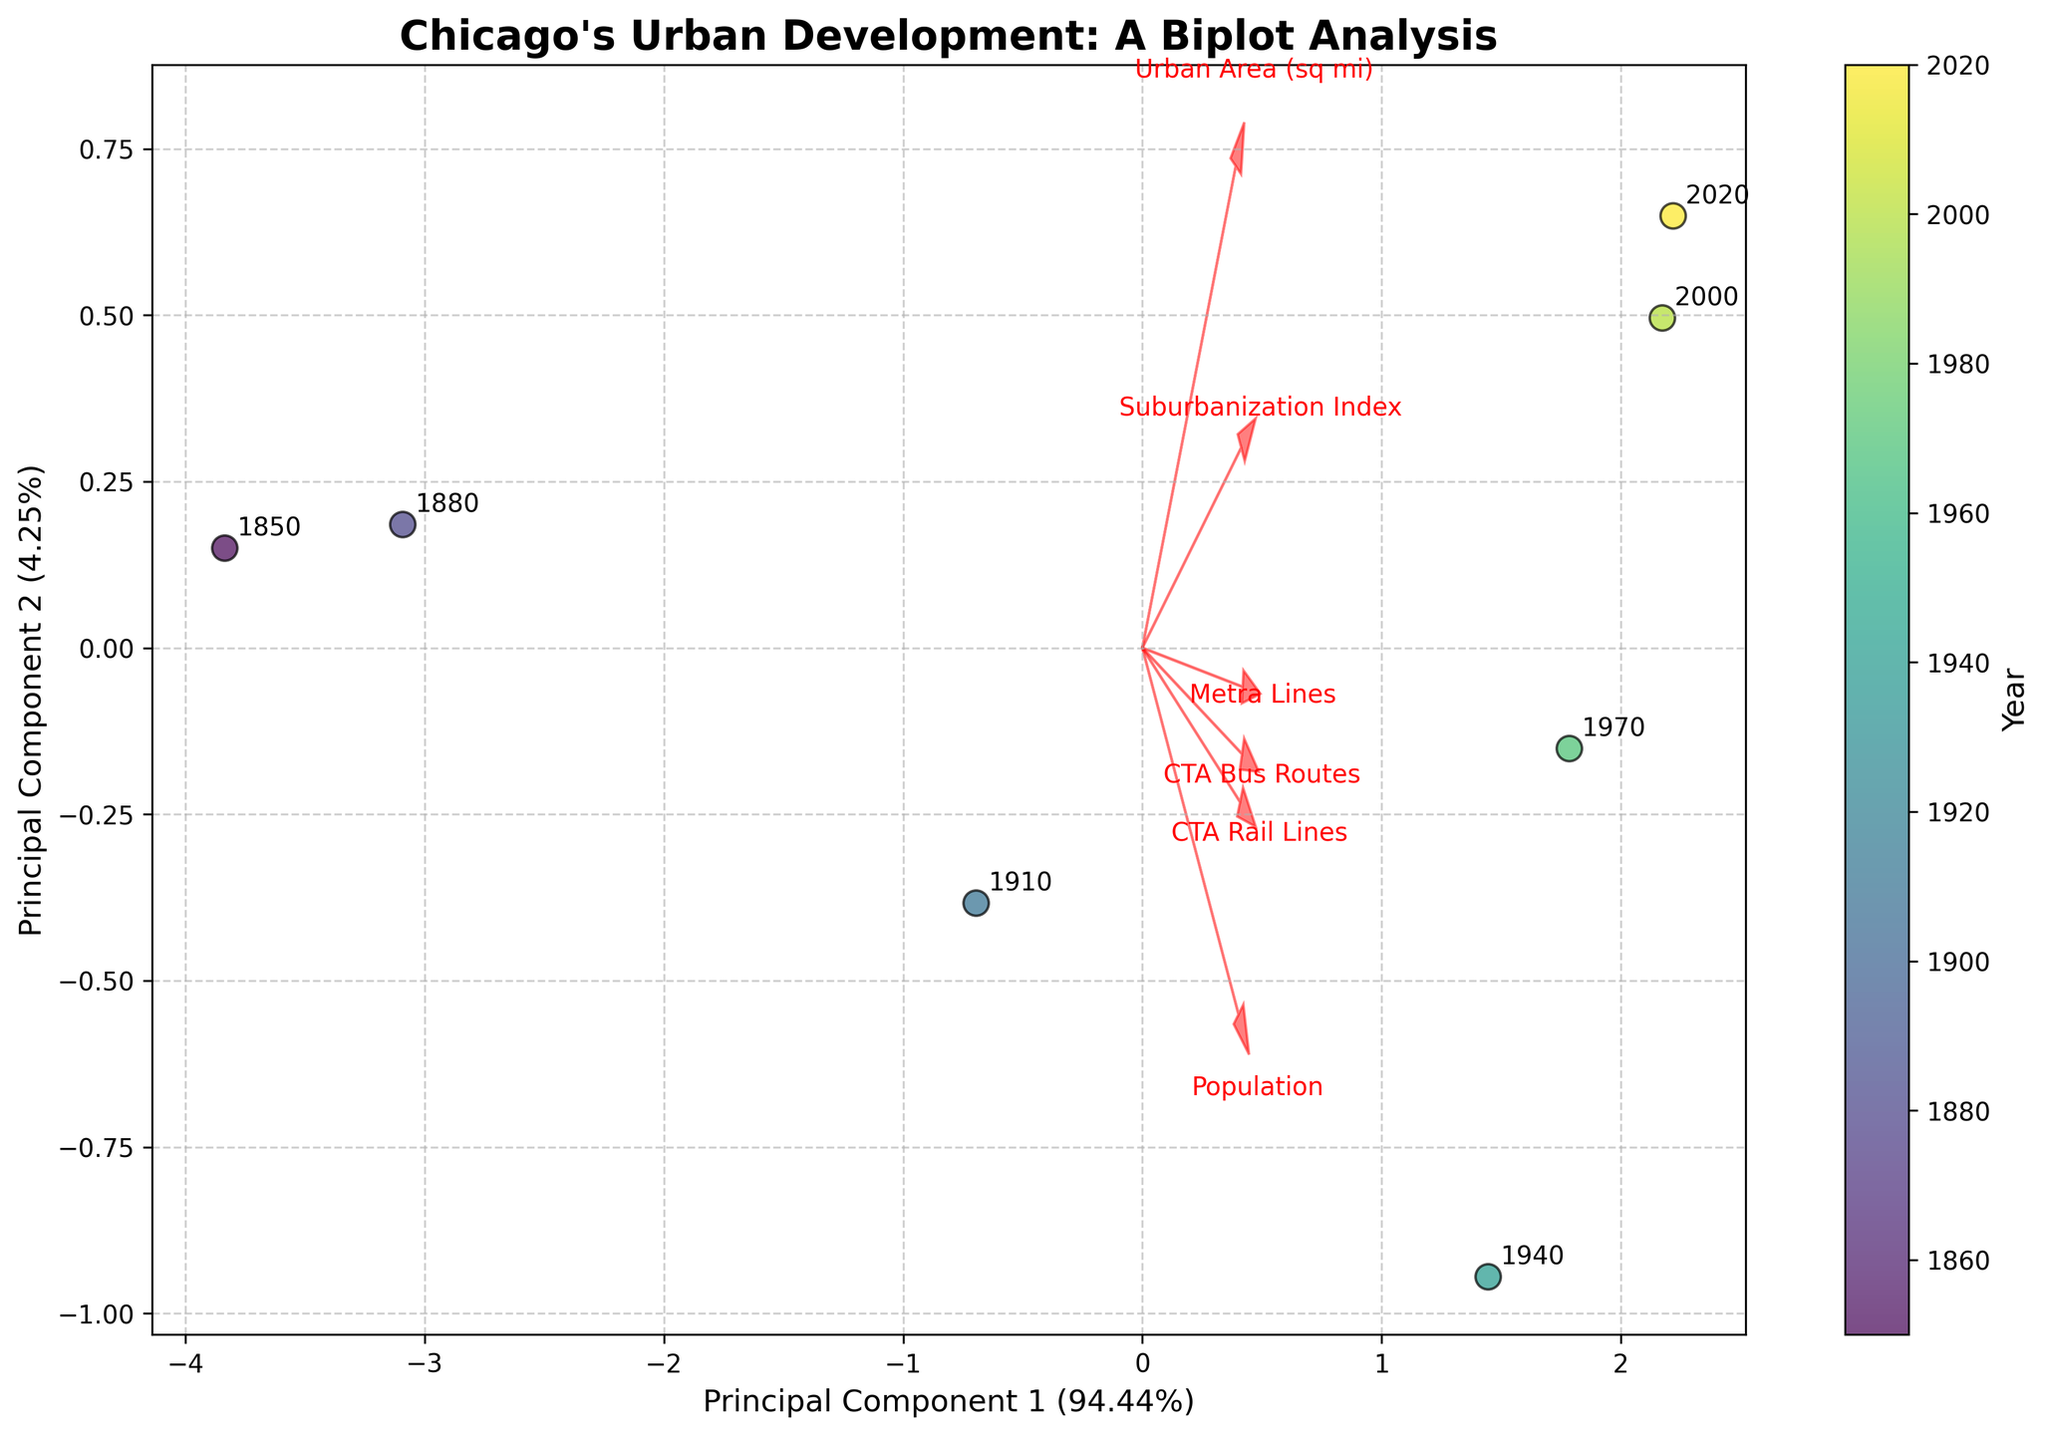How many principal components are used in the biplot? The figure shows a biplot with two principal components, evident from seeing “Principal Component 1” and “Principal Component 2” mentioned on the x-axis and y-axis.
Answer: Two What is the feature with the longest vector in the plot? The length of the vector in a biplot indicates the significance of the feature in the principal component analysis. By visually inspecting the vectors, the feature "Population" has the longest vector.
Answer: Population Which year appears closest to the origin (0,0) on the biplot? By looking at the positions of the year labels in the biplot, the year 2000 appears closest to the origin of the plot.
Answer: 2000 What is the title of the biplot? The title of the biplot is located at the top of the figure and reads "Chicago's Urban Development: A Biplot Analysis."
Answer: Chicago's Urban Development: A Biplot Analysis How many data points are represented in the plot? Each year from the provided dataset is represented by a data point in the biplot. The years listed are 1850, 1880, 1910, 1940, 1970, 2000, and 2020, making a total of seven data points.
Answer: Seven Which feature vectors are positively correlated with each other? In a biplot, features pointing in similar directions are positively correlated. By inspecting the plot, "CTA Bus Routes" and "CTA Rail Lines" vectors point in somewhat similar directions, indicating a positive correlation.
Answer: CTA Bus Routes and CTA Rail Lines Which principal component explains more variance and by how much? The x-axis corresponds to Principal Component 1 and the y-axis to Principal Component 2. By examining the labels, Principal Component 1 explains more variance, with a variance proportion of 71.78% versus 16.34% for Principal Component 2.
Answer: Principal Component 1 by 55.44% How does the Urban Area (sq mi) vector relate to the Suburbanization Index vector? In the biplot, "Urban Area (sq mi)" and "Suburbanization Index" vectors point in nearly the same direction, indicating they are positively correlated.
Answer: Positively correlated Which year shows the highest Suburbanization Index in the biplot? In the biplot, the point farthest along the direction of the "Suburbanization Index" vector would indicate the highest value. The year 2020 is the farthest, indicating the highest Suburbanization Index.
Answer: 2020 